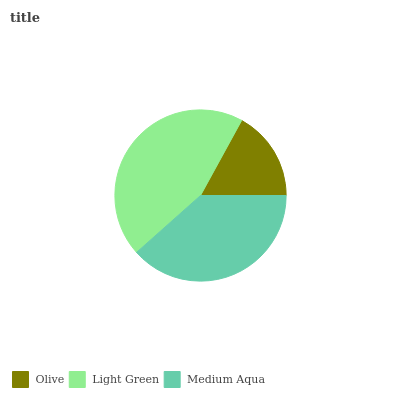Is Olive the minimum?
Answer yes or no. Yes. Is Light Green the maximum?
Answer yes or no. Yes. Is Medium Aqua the minimum?
Answer yes or no. No. Is Medium Aqua the maximum?
Answer yes or no. No. Is Light Green greater than Medium Aqua?
Answer yes or no. Yes. Is Medium Aqua less than Light Green?
Answer yes or no. Yes. Is Medium Aqua greater than Light Green?
Answer yes or no. No. Is Light Green less than Medium Aqua?
Answer yes or no. No. Is Medium Aqua the high median?
Answer yes or no. Yes. Is Medium Aqua the low median?
Answer yes or no. Yes. Is Light Green the high median?
Answer yes or no. No. Is Light Green the low median?
Answer yes or no. No. 